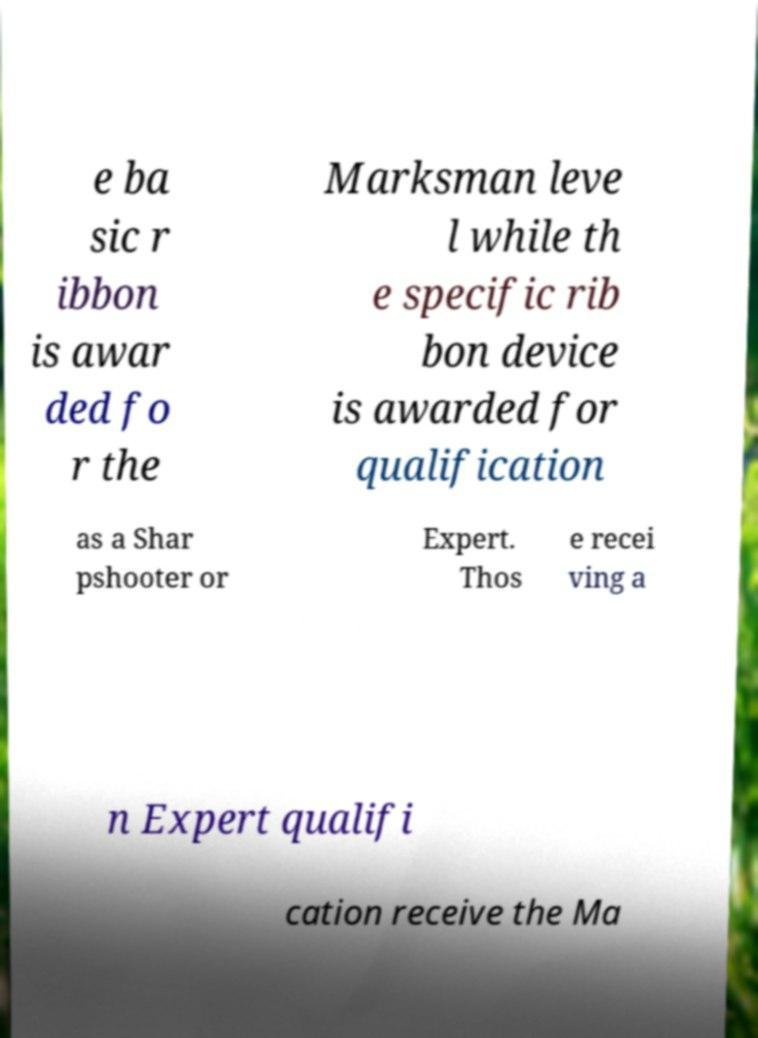I need the written content from this picture converted into text. Can you do that? e ba sic r ibbon is awar ded fo r the Marksman leve l while th e specific rib bon device is awarded for qualification as a Shar pshooter or Expert. Thos e recei ving a n Expert qualifi cation receive the Ma 